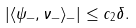<formula> <loc_0><loc_0><loc_500><loc_500>| \langle \psi _ { - } , \nu _ { - } \rangle _ { - } | \leq c _ { 2 } \delta .</formula> 